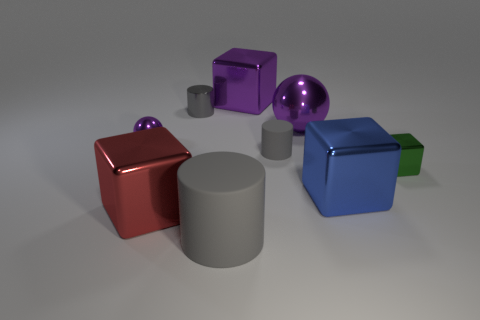Add 1 tiny gray objects. How many objects exist? 10 Subtract all cylinders. How many objects are left? 6 Subtract all purple matte cubes. Subtract all metal cubes. How many objects are left? 5 Add 5 gray matte cylinders. How many gray matte cylinders are left? 7 Add 3 tiny green metal cubes. How many tiny green metal cubes exist? 4 Subtract 0 cyan cylinders. How many objects are left? 9 